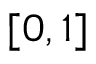Convert formula to latex. <formula><loc_0><loc_0><loc_500><loc_500>[ 0 , 1 ]</formula> 